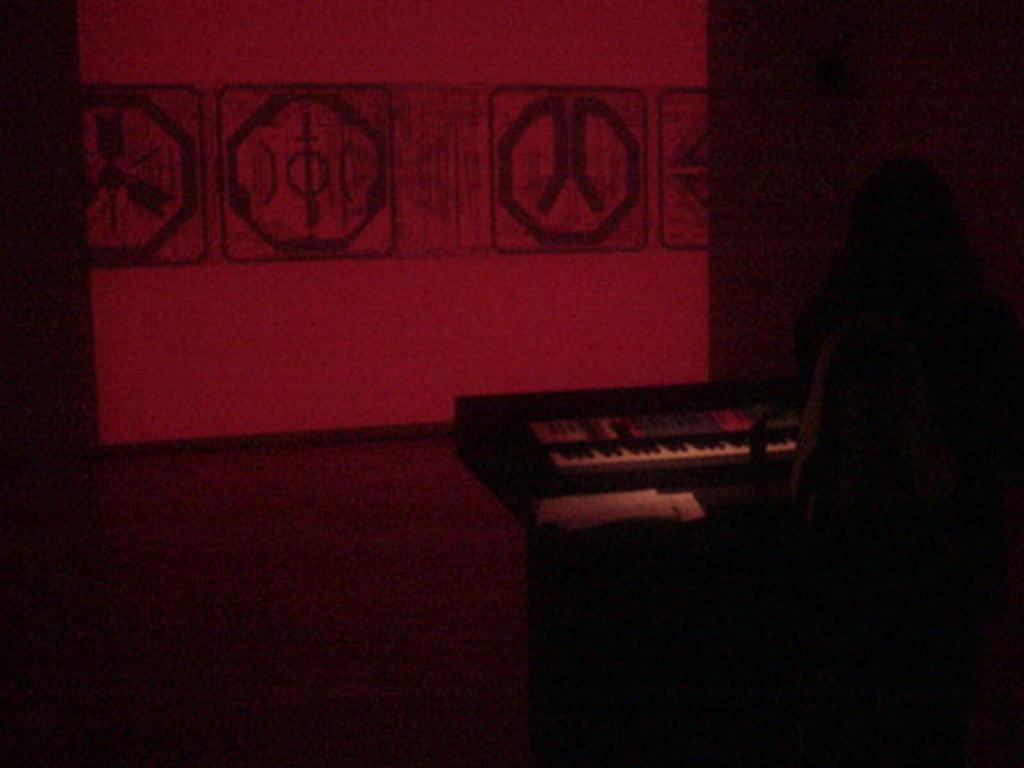How would you summarize this image in a sentence or two? This picture is completely blurry and dark. Here we can see a person playing a musical instrument, piano. On the background we can see a screen. 